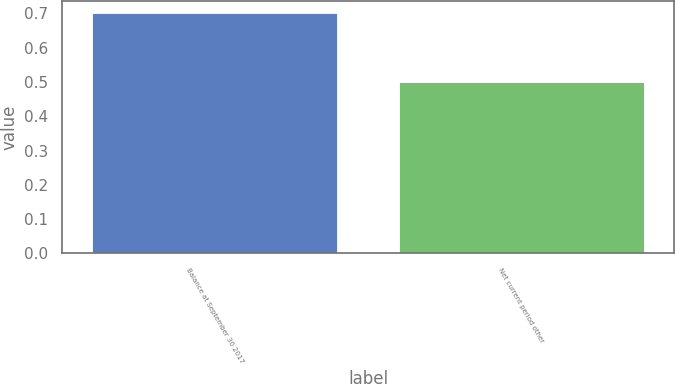<chart> <loc_0><loc_0><loc_500><loc_500><bar_chart><fcel>Balance at September 30 2017<fcel>Net current period other<nl><fcel>0.7<fcel>0.5<nl></chart> 